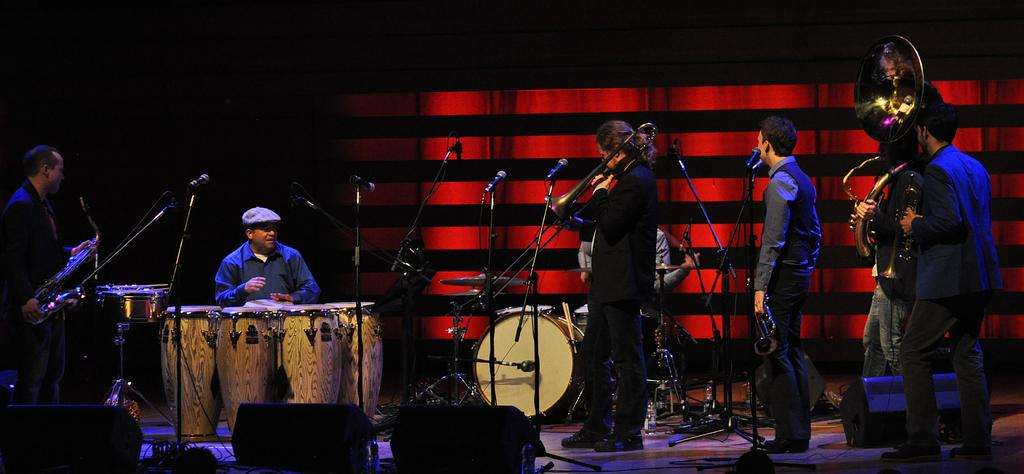What is the main subject of the image? The image depicts a stage show. What are the people on the stage doing? Some people are standing on the stage, and at least one person is sitting on the stage. What is the person sitting doing? The person sitting is playing a musical instrument. What type of grip does the pan have in the image? There is no pan present in the image; it features a stage show with people performing. 